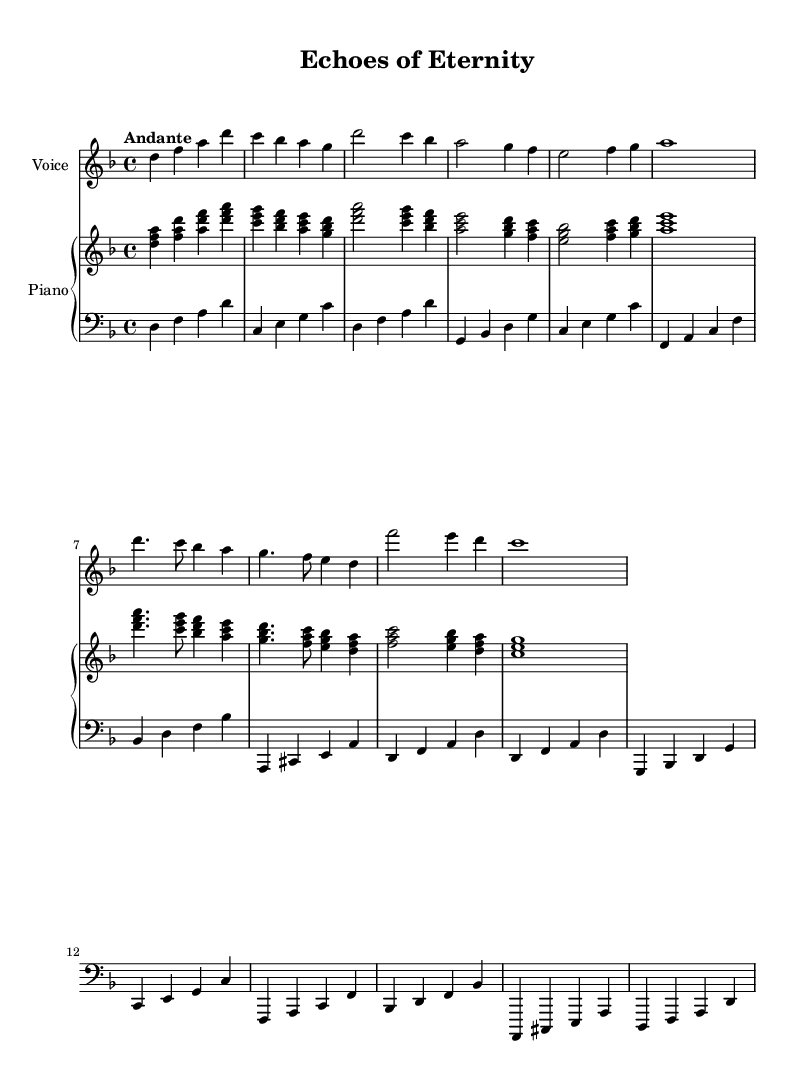What is the key signature of this music? The key signature is indicated at the beginning of the score. It has one flat, which corresponds to the key of D minor.
Answer: D minor What is the time signature of this music? The time signature is shown at the beginning of the piece. It is written as "4/4," indicating four beats per measure.
Answer: 4/4 What is the specified tempo of this piece? The tempo indication is found above the staff. It states "Andante," which refers to a moderately slow tempo.
Answer: Andante How many measures are there in the chorus section? To answer this, count the measures in the chorus section. The chorus consists of 4 measures.
Answer: 4 What is the final note of the piece? The final note is at the end of the score, which is indicated on the last beat. The last note is a D in the bass clef.
Answer: D Which voice part is the highest in this piece? By examining the staves, the "Voice" part is located on the highest staff, indicating it is the soprano voice.
Answer: Voice What is a common feature observed in Baroque opera arias within this score? The score includes expressive melismas, where several notes are sung on one syllable, which is typical for Baroque opera.
Answer: Melismas 